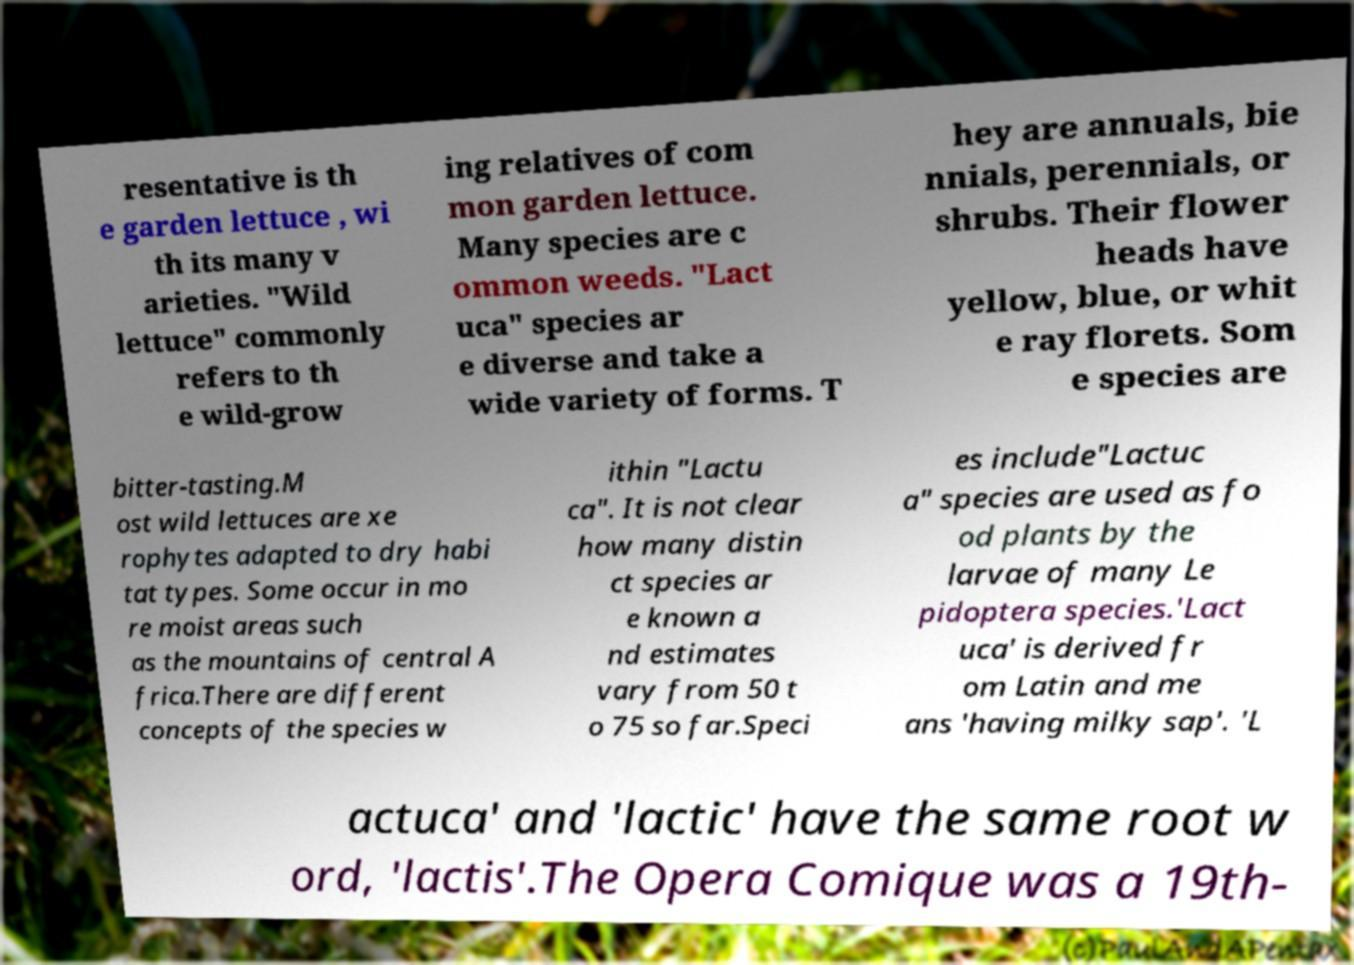There's text embedded in this image that I need extracted. Can you transcribe it verbatim? resentative is th e garden lettuce , wi th its many v arieties. "Wild lettuce" commonly refers to th e wild-grow ing relatives of com mon garden lettuce. Many species are c ommon weeds. "Lact uca" species ar e diverse and take a wide variety of forms. T hey are annuals, bie nnials, perennials, or shrubs. Their flower heads have yellow, blue, or whit e ray florets. Som e species are bitter-tasting.M ost wild lettuces are xe rophytes adapted to dry habi tat types. Some occur in mo re moist areas such as the mountains of central A frica.There are different concepts of the species w ithin "Lactu ca". It is not clear how many distin ct species ar e known a nd estimates vary from 50 t o 75 so far.Speci es include"Lactuc a" species are used as fo od plants by the larvae of many Le pidoptera species.'Lact uca' is derived fr om Latin and me ans 'having milky sap'. 'L actuca' and 'lactic' have the same root w ord, 'lactis'.The Opera Comique was a 19th- 